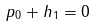Convert formula to latex. <formula><loc_0><loc_0><loc_500><loc_500>p _ { 0 } + h _ { 1 } = 0</formula> 